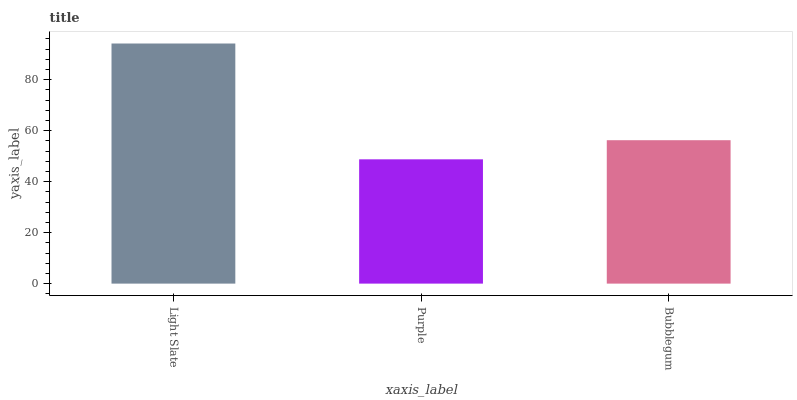Is Purple the minimum?
Answer yes or no. Yes. Is Light Slate the maximum?
Answer yes or no. Yes. Is Bubblegum the minimum?
Answer yes or no. No. Is Bubblegum the maximum?
Answer yes or no. No. Is Bubblegum greater than Purple?
Answer yes or no. Yes. Is Purple less than Bubblegum?
Answer yes or no. Yes. Is Purple greater than Bubblegum?
Answer yes or no. No. Is Bubblegum less than Purple?
Answer yes or no. No. Is Bubblegum the high median?
Answer yes or no. Yes. Is Bubblegum the low median?
Answer yes or no. Yes. Is Purple the high median?
Answer yes or no. No. Is Purple the low median?
Answer yes or no. No. 